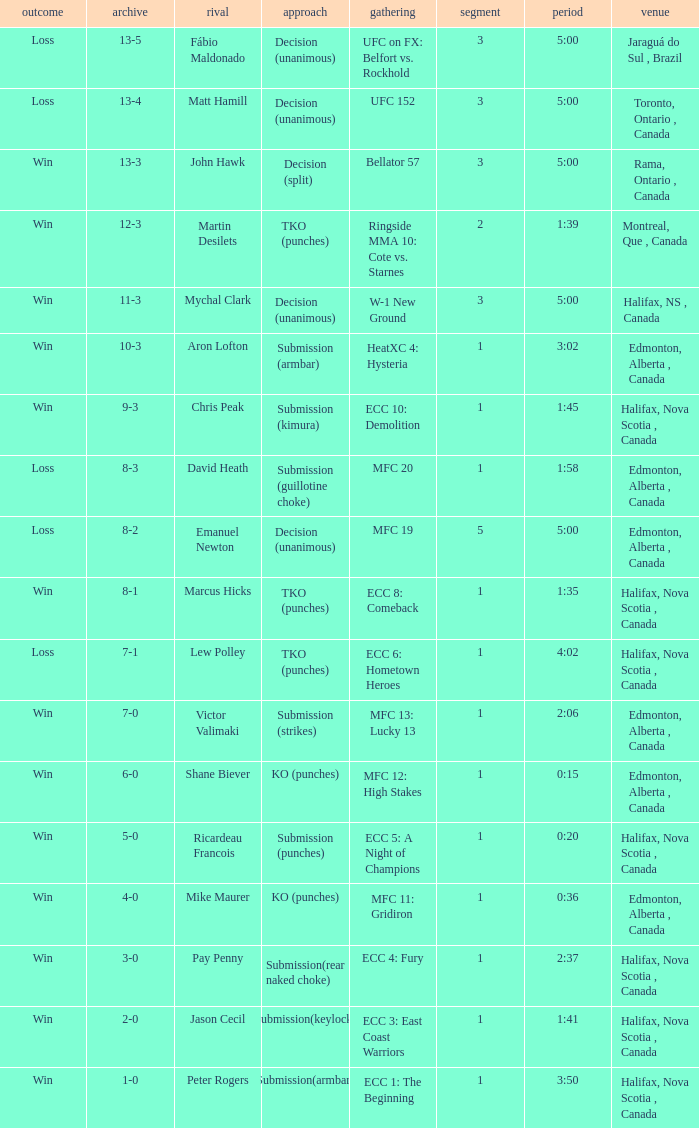Can you parse all the data within this table? {'header': ['outcome', 'archive', 'rival', 'approach', 'gathering', 'segment', 'period', 'venue'], 'rows': [['Loss', '13-5', 'Fábio Maldonado', 'Decision (unanimous)', 'UFC on FX: Belfort vs. Rockhold', '3', '5:00', 'Jaraguá do Sul , Brazil'], ['Loss', '13-4', 'Matt Hamill', 'Decision (unanimous)', 'UFC 152', '3', '5:00', 'Toronto, Ontario , Canada'], ['Win', '13-3', 'John Hawk', 'Decision (split)', 'Bellator 57', '3', '5:00', 'Rama, Ontario , Canada'], ['Win', '12-3', 'Martin Desilets', 'TKO (punches)', 'Ringside MMA 10: Cote vs. Starnes', '2', '1:39', 'Montreal, Que , Canada'], ['Win', '11-3', 'Mychal Clark', 'Decision (unanimous)', 'W-1 New Ground', '3', '5:00', 'Halifax, NS , Canada'], ['Win', '10-3', 'Aron Lofton', 'Submission (armbar)', 'HeatXC 4: Hysteria', '1', '3:02', 'Edmonton, Alberta , Canada'], ['Win', '9-3', 'Chris Peak', 'Submission (kimura)', 'ECC 10: Demolition', '1', '1:45', 'Halifax, Nova Scotia , Canada'], ['Loss', '8-3', 'David Heath', 'Submission (guillotine choke)', 'MFC 20', '1', '1:58', 'Edmonton, Alberta , Canada'], ['Loss', '8-2', 'Emanuel Newton', 'Decision (unanimous)', 'MFC 19', '5', '5:00', 'Edmonton, Alberta , Canada'], ['Win', '8-1', 'Marcus Hicks', 'TKO (punches)', 'ECC 8: Comeback', '1', '1:35', 'Halifax, Nova Scotia , Canada'], ['Loss', '7-1', 'Lew Polley', 'TKO (punches)', 'ECC 6: Hometown Heroes', '1', '4:02', 'Halifax, Nova Scotia , Canada'], ['Win', '7-0', 'Victor Valimaki', 'Submission (strikes)', 'MFC 13: Lucky 13', '1', '2:06', 'Edmonton, Alberta , Canada'], ['Win', '6-0', 'Shane Biever', 'KO (punches)', 'MFC 12: High Stakes', '1', '0:15', 'Edmonton, Alberta , Canada'], ['Win', '5-0', 'Ricardeau Francois', 'Submission (punches)', 'ECC 5: A Night of Champions', '1', '0:20', 'Halifax, Nova Scotia , Canada'], ['Win', '4-0', 'Mike Maurer', 'KO (punches)', 'MFC 11: Gridiron', '1', '0:36', 'Edmonton, Alberta , Canada'], ['Win', '3-0', 'Pay Penny', 'Submission(rear naked choke)', 'ECC 4: Fury', '1', '2:37', 'Halifax, Nova Scotia , Canada'], ['Win', '2-0', 'Jason Cecil', 'Submission(keylock)', 'ECC 3: East Coast Warriors', '1', '1:41', 'Halifax, Nova Scotia , Canada'], ['Win', '1-0', 'Peter Rogers', 'Submission(armbar)', 'ECC 1: The Beginning', '1', '3:50', 'Halifax, Nova Scotia , Canada']]} What is the location of the match with an event of ecc 8: comeback? Halifax, Nova Scotia , Canada. 